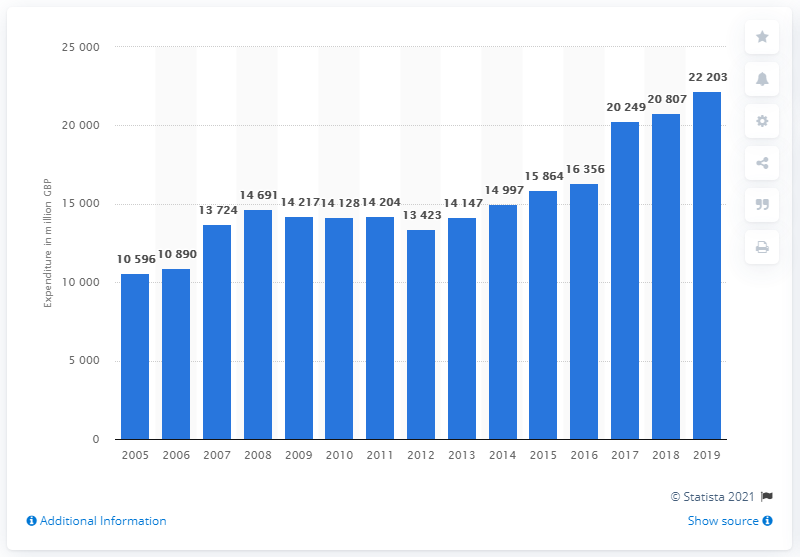Point out several critical features in this image. In 2019, UK households purchased approximately 22,203 pounds worth of games, toys, and other items related to hobbies. 